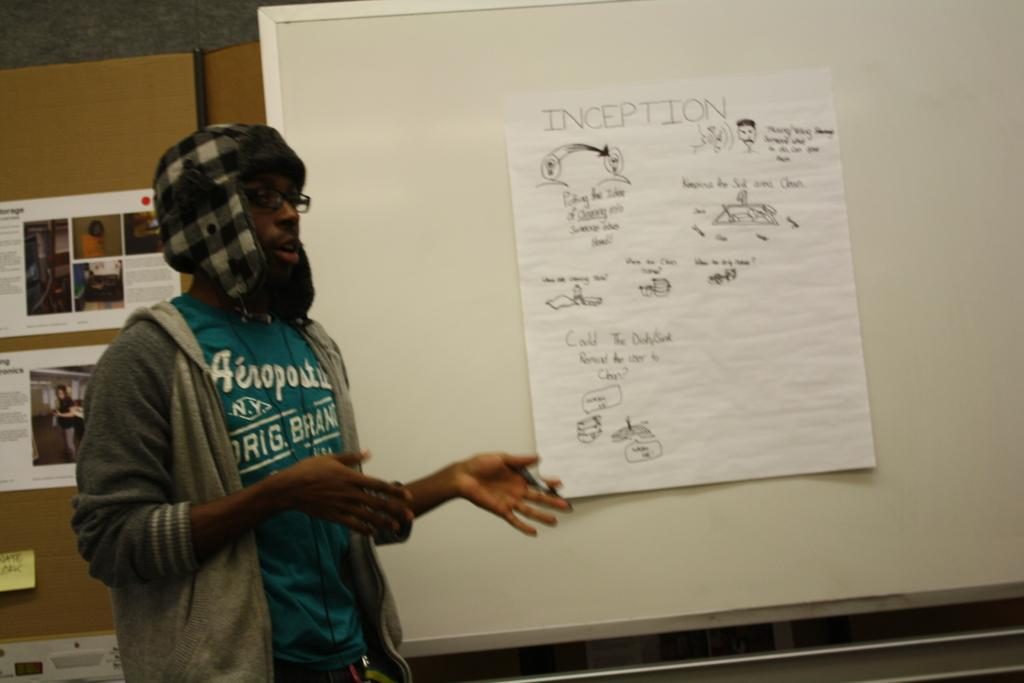<image>
Describe the image concisely. A man stands in front of a whiteboard pointing to a page titled Inception. 